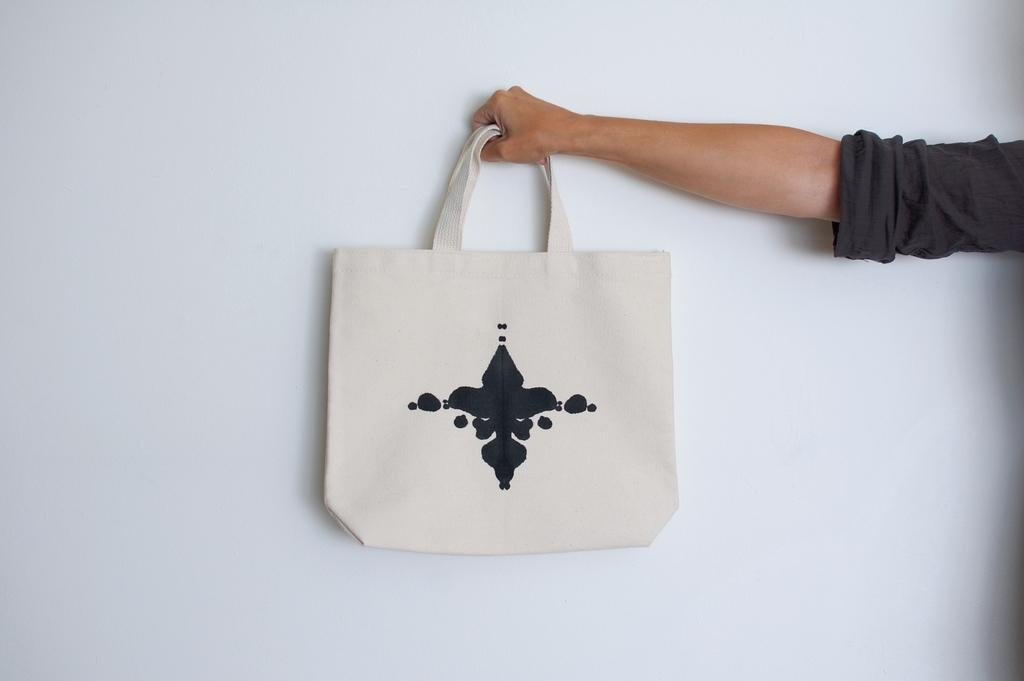What is the main subject of the image? The main subject of the image is a human hand. What is the hand holding in the image? The hand is holding a bag. What type of cloth is covering the face of the person in the image? There is no person or cloth covering a face present in the image; it only features a human hand holding a bag. 